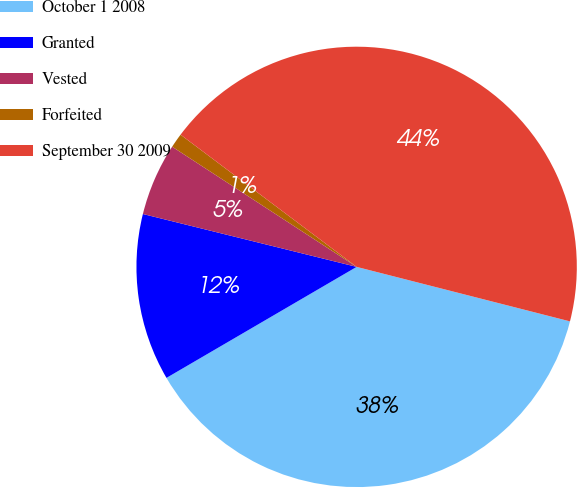<chart> <loc_0><loc_0><loc_500><loc_500><pie_chart><fcel>October 1 2008<fcel>Granted<fcel>Vested<fcel>Forfeited<fcel>September 30 2009<nl><fcel>37.61%<fcel>12.27%<fcel>5.33%<fcel>1.06%<fcel>43.73%<nl></chart> 